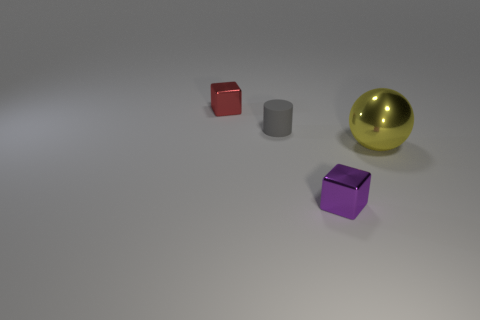Add 2 large yellow metallic spheres. How many objects exist? 6 Subtract all cylinders. How many objects are left? 3 Add 4 big brown matte cylinders. How many big brown matte cylinders exist? 4 Subtract 0 cyan cylinders. How many objects are left? 4 Subtract all brown matte cylinders. Subtract all matte objects. How many objects are left? 3 Add 4 big yellow shiny objects. How many big yellow shiny objects are left? 5 